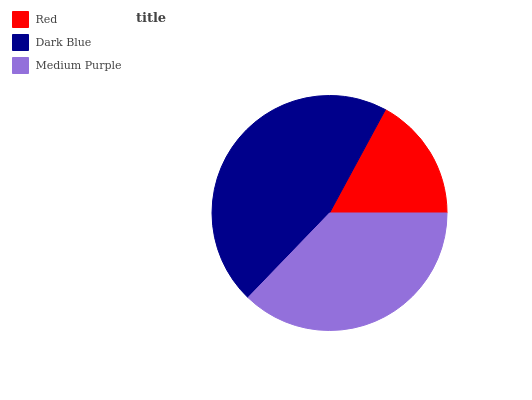Is Red the minimum?
Answer yes or no. Yes. Is Dark Blue the maximum?
Answer yes or no. Yes. Is Medium Purple the minimum?
Answer yes or no. No. Is Medium Purple the maximum?
Answer yes or no. No. Is Dark Blue greater than Medium Purple?
Answer yes or no. Yes. Is Medium Purple less than Dark Blue?
Answer yes or no. Yes. Is Medium Purple greater than Dark Blue?
Answer yes or no. No. Is Dark Blue less than Medium Purple?
Answer yes or no. No. Is Medium Purple the high median?
Answer yes or no. Yes. Is Medium Purple the low median?
Answer yes or no. Yes. Is Red the high median?
Answer yes or no. No. Is Red the low median?
Answer yes or no. No. 